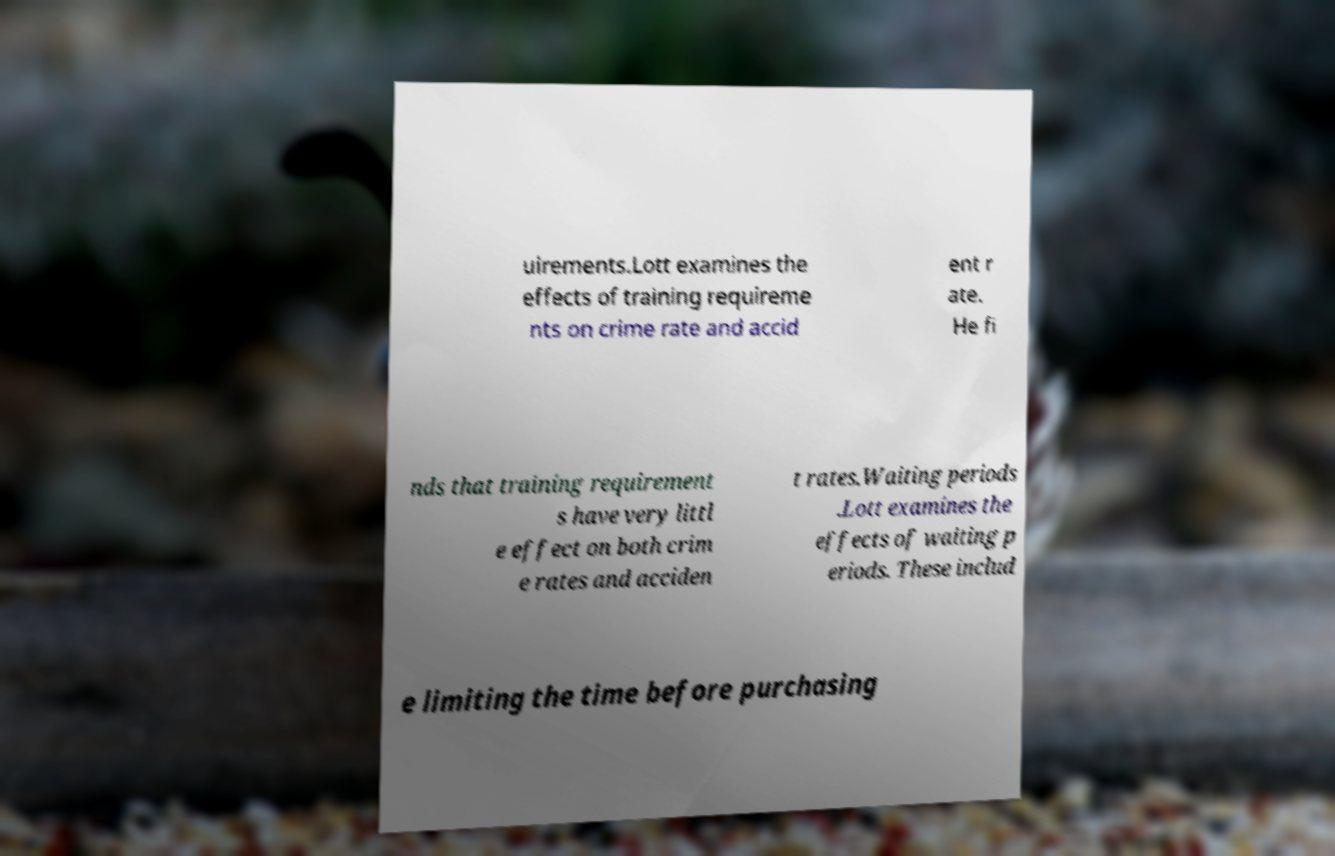What messages or text are displayed in this image? I need them in a readable, typed format. uirements.Lott examines the effects of training requireme nts on crime rate and accid ent r ate. He fi nds that training requirement s have very littl e effect on both crim e rates and acciden t rates.Waiting periods .Lott examines the effects of waiting p eriods. These includ e limiting the time before purchasing 